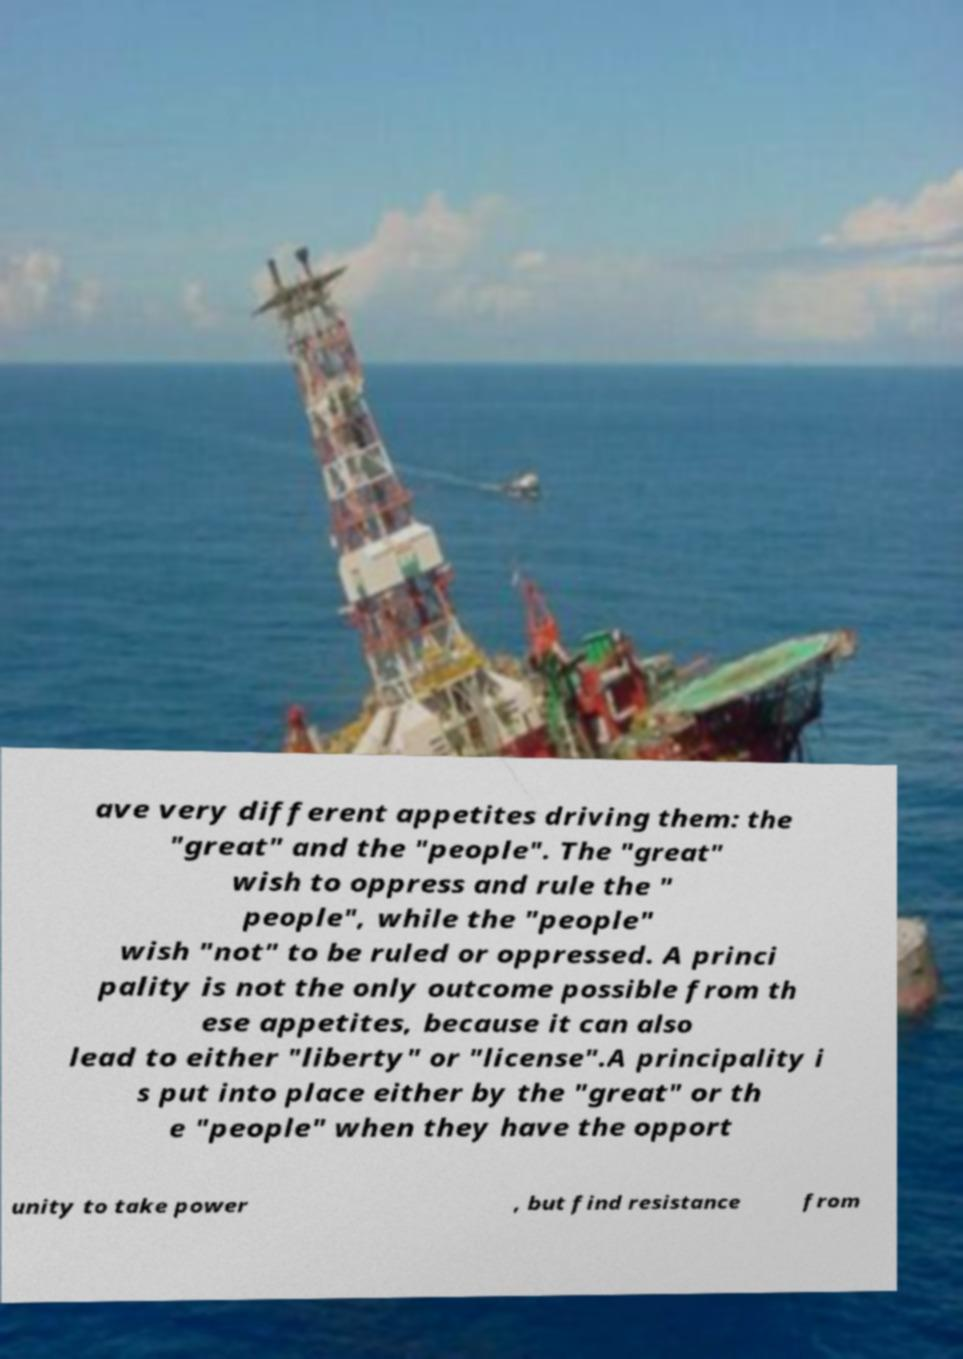For documentation purposes, I need the text within this image transcribed. Could you provide that? ave very different appetites driving them: the "great" and the "people". The "great" wish to oppress and rule the " people", while the "people" wish "not" to be ruled or oppressed. A princi pality is not the only outcome possible from th ese appetites, because it can also lead to either "liberty" or "license".A principality i s put into place either by the "great" or th e "people" when they have the opport unity to take power , but find resistance from 